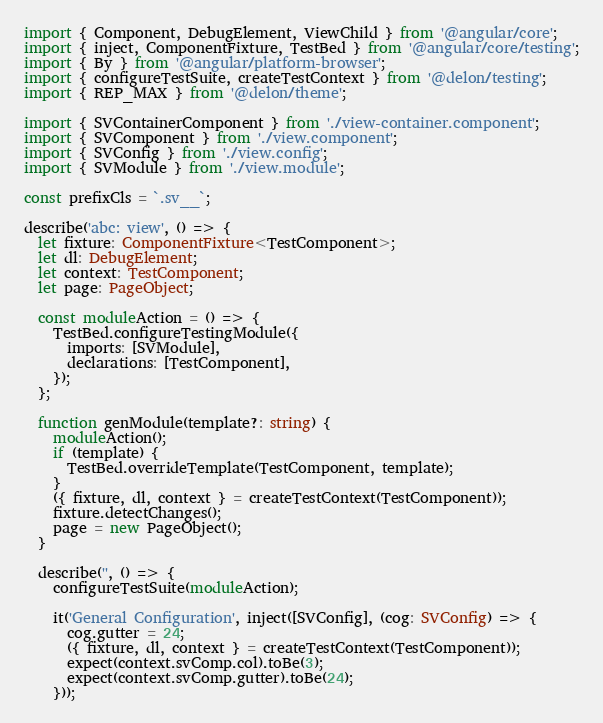<code> <loc_0><loc_0><loc_500><loc_500><_TypeScript_>import { Component, DebugElement, ViewChild } from '@angular/core';
import { inject, ComponentFixture, TestBed } from '@angular/core/testing';
import { By } from '@angular/platform-browser';
import { configureTestSuite, createTestContext } from '@delon/testing';
import { REP_MAX } from '@delon/theme';

import { SVContainerComponent } from './view-container.component';
import { SVComponent } from './view.component';
import { SVConfig } from './view.config';
import { SVModule } from './view.module';

const prefixCls = `.sv__`;

describe('abc: view', () => {
  let fixture: ComponentFixture<TestComponent>;
  let dl: DebugElement;
  let context: TestComponent;
  let page: PageObject;

  const moduleAction = () => {
    TestBed.configureTestingModule({
      imports: [SVModule],
      declarations: [TestComponent],
    });
  };

  function genModule(template?: string) {
    moduleAction();
    if (template) {
      TestBed.overrideTemplate(TestComponent, template);
    }
    ({ fixture, dl, context } = createTestContext(TestComponent));
    fixture.detectChanges();
    page = new PageObject();
  }

  describe('', () => {
    configureTestSuite(moduleAction);

    it('General Configuration', inject([SVConfig], (cog: SVConfig) => {
      cog.gutter = 24;
      ({ fixture, dl, context } = createTestContext(TestComponent));
      expect(context.svComp.col).toBe(3);
      expect(context.svComp.gutter).toBe(24);
    }));
</code> 